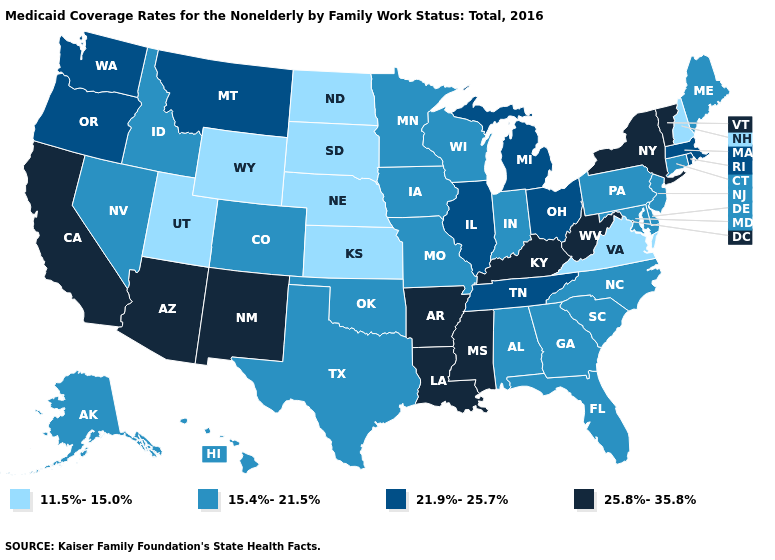Does South Dakota have the lowest value in the USA?
Keep it brief. Yes. What is the value of Nevada?
Quick response, please. 15.4%-21.5%. What is the lowest value in the West?
Answer briefly. 11.5%-15.0%. Does Arizona have a higher value than Colorado?
Keep it brief. Yes. Which states have the lowest value in the USA?
Concise answer only. Kansas, Nebraska, New Hampshire, North Dakota, South Dakota, Utah, Virginia, Wyoming. What is the highest value in the USA?
Answer briefly. 25.8%-35.8%. Which states have the highest value in the USA?
Short answer required. Arizona, Arkansas, California, Kentucky, Louisiana, Mississippi, New Mexico, New York, Vermont, West Virginia. What is the value of Georgia?
Be succinct. 15.4%-21.5%. What is the value of Massachusetts?
Write a very short answer. 21.9%-25.7%. What is the highest value in the USA?
Give a very brief answer. 25.8%-35.8%. Among the states that border Ohio , does Michigan have the lowest value?
Be succinct. No. What is the value of Indiana?
Concise answer only. 15.4%-21.5%. Name the states that have a value in the range 11.5%-15.0%?
Short answer required. Kansas, Nebraska, New Hampshire, North Dakota, South Dakota, Utah, Virginia, Wyoming. What is the value of Connecticut?
Quick response, please. 15.4%-21.5%. 